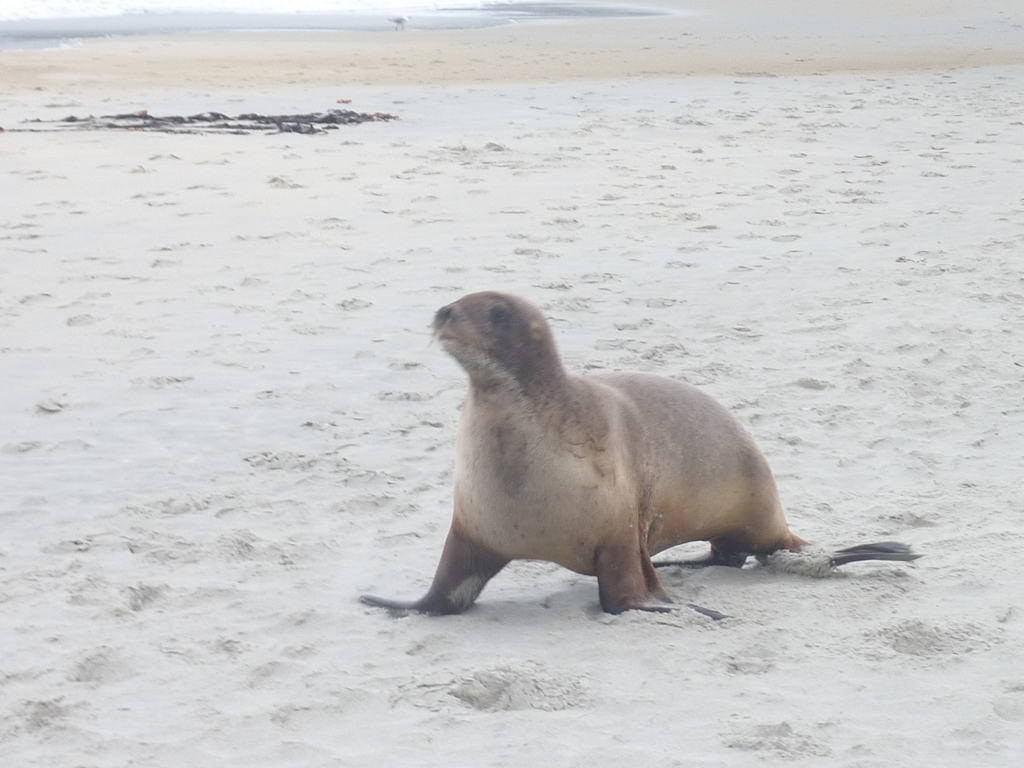What is the animal featured in the image, and what is it doing? The animal is a seal, and it appears to be mid-movement, perhaps walking or adjusting its position on the sand. 